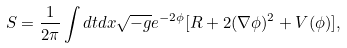Convert formula to latex. <formula><loc_0><loc_0><loc_500><loc_500>S = \frac { 1 } { 2 \pi } \int d t d x \sqrt { - g } e ^ { - 2 \phi } [ R + 2 ( \nabla \phi ) ^ { 2 } + V ( \phi ) ] ,</formula> 